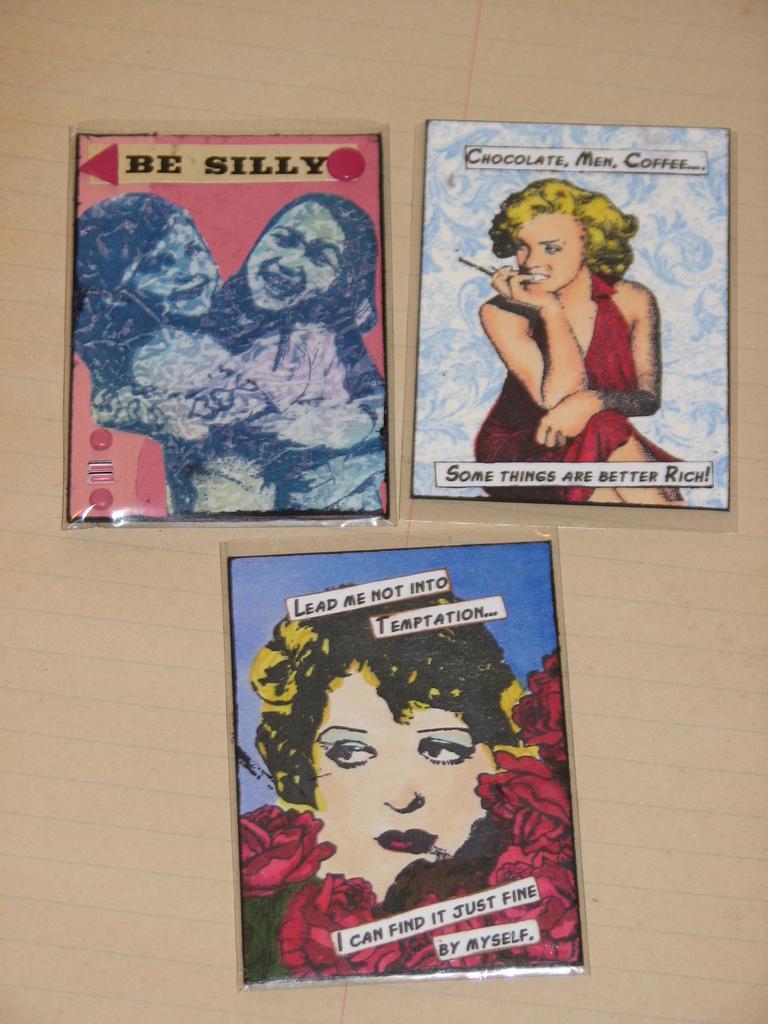Describe this image in one or two sentences. In this image I can see pictures and plastic covers are on the paper. In these pictures I can see images of people and flowers. Something is written on these pictures.   